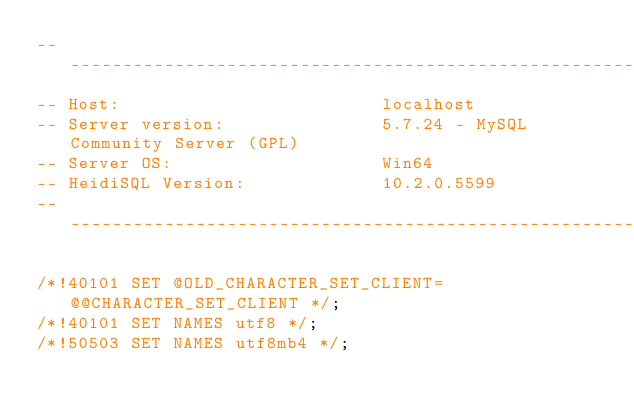<code> <loc_0><loc_0><loc_500><loc_500><_SQL_>-- --------------------------------------------------------
-- Host:                         localhost
-- Server version:               5.7.24 - MySQL Community Server (GPL)
-- Server OS:                    Win64
-- HeidiSQL Version:             10.2.0.5599
-- --------------------------------------------------------

/*!40101 SET @OLD_CHARACTER_SET_CLIENT=@@CHARACTER_SET_CLIENT */;
/*!40101 SET NAMES utf8 */;
/*!50503 SET NAMES utf8mb4 */;</code> 